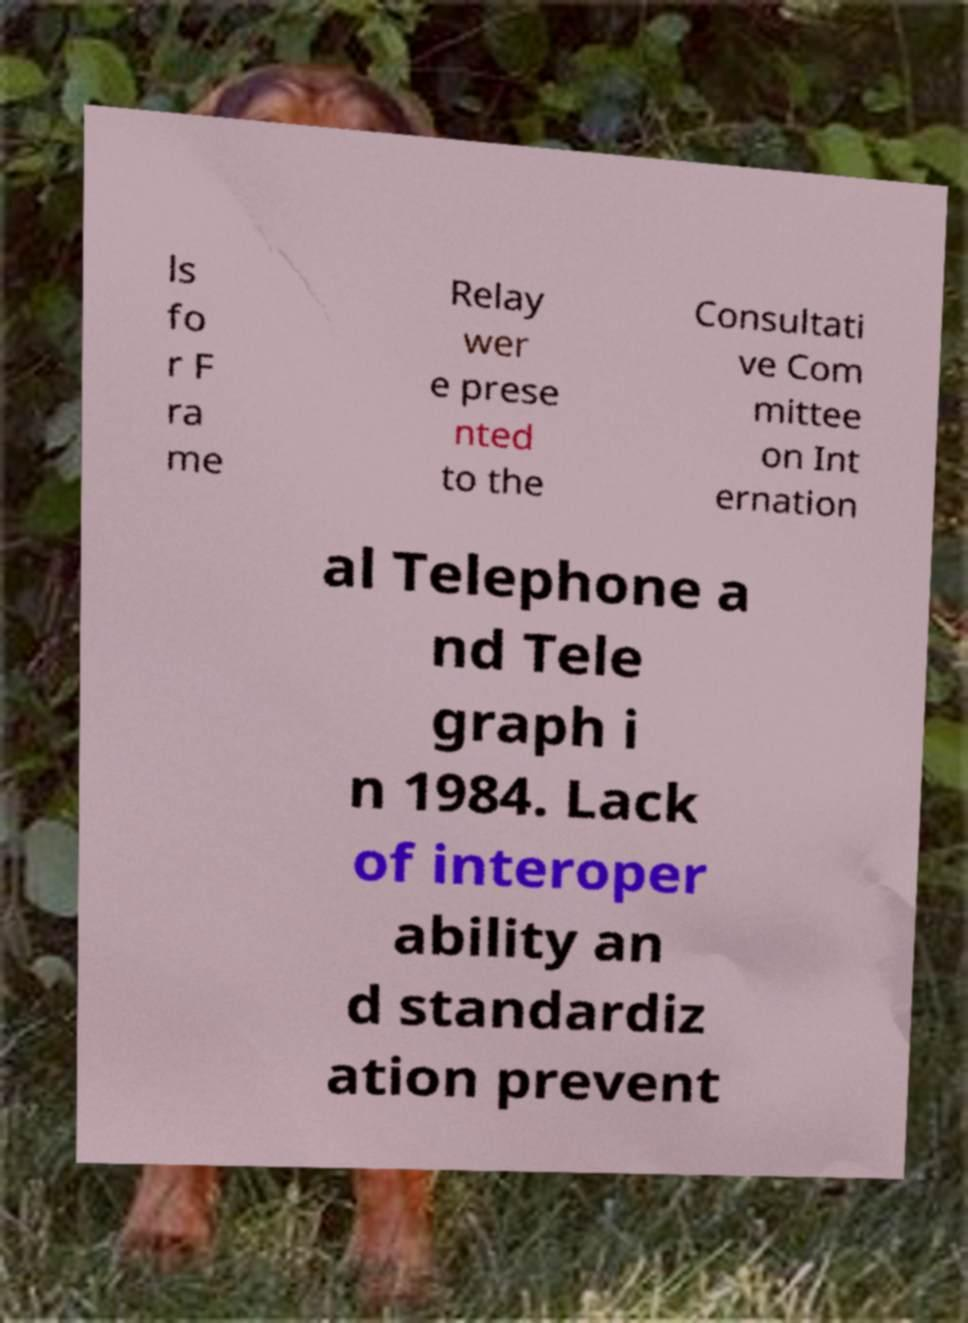Could you assist in decoding the text presented in this image and type it out clearly? ls fo r F ra me Relay wer e prese nted to the Consultati ve Com mittee on Int ernation al Telephone a nd Tele graph i n 1984. Lack of interoper ability an d standardiz ation prevent 